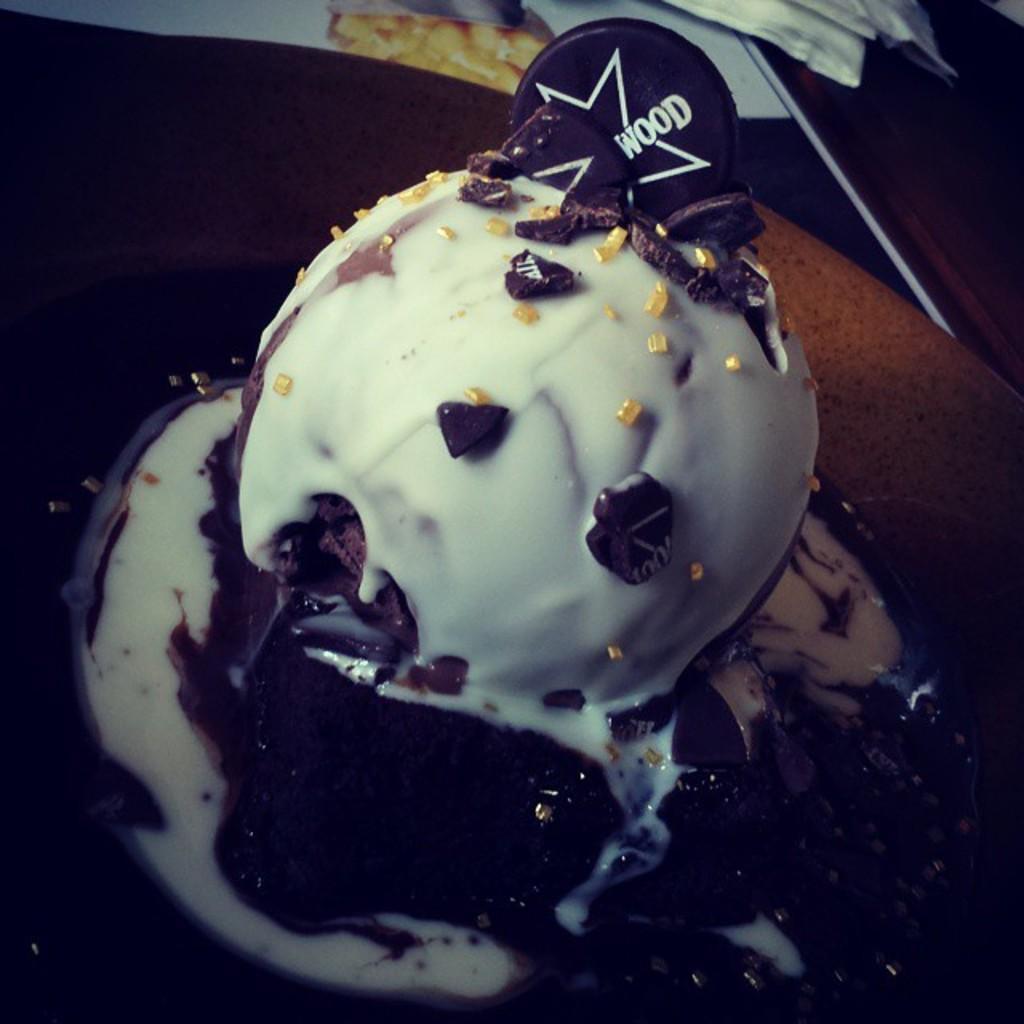Describe this image in one or two sentences. In this image we can see a food item in a plate with chocolate topping and we can see the plate placed on a table. 